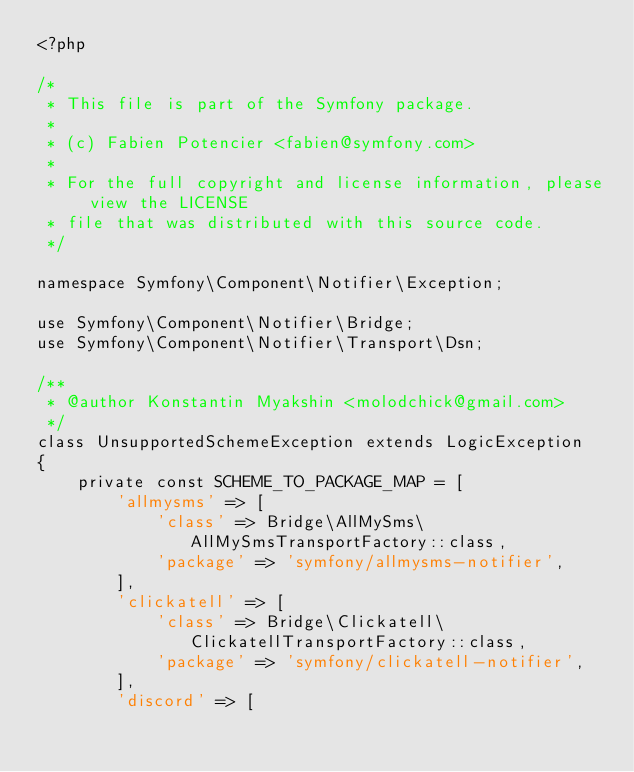Convert code to text. <code><loc_0><loc_0><loc_500><loc_500><_PHP_><?php

/*
 * This file is part of the Symfony package.
 *
 * (c) Fabien Potencier <fabien@symfony.com>
 *
 * For the full copyright and license information, please view the LICENSE
 * file that was distributed with this source code.
 */

namespace Symfony\Component\Notifier\Exception;

use Symfony\Component\Notifier\Bridge;
use Symfony\Component\Notifier\Transport\Dsn;

/**
 * @author Konstantin Myakshin <molodchick@gmail.com>
 */
class UnsupportedSchemeException extends LogicException
{
    private const SCHEME_TO_PACKAGE_MAP = [
        'allmysms' => [
            'class' => Bridge\AllMySms\AllMySmsTransportFactory::class,
            'package' => 'symfony/allmysms-notifier',
        ],
        'clickatell' => [
            'class' => Bridge\Clickatell\ClickatellTransportFactory::class,
            'package' => 'symfony/clickatell-notifier',
        ],
        'discord' => [</code> 